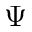Convert formula to latex. <formula><loc_0><loc_0><loc_500><loc_500>\Psi</formula> 